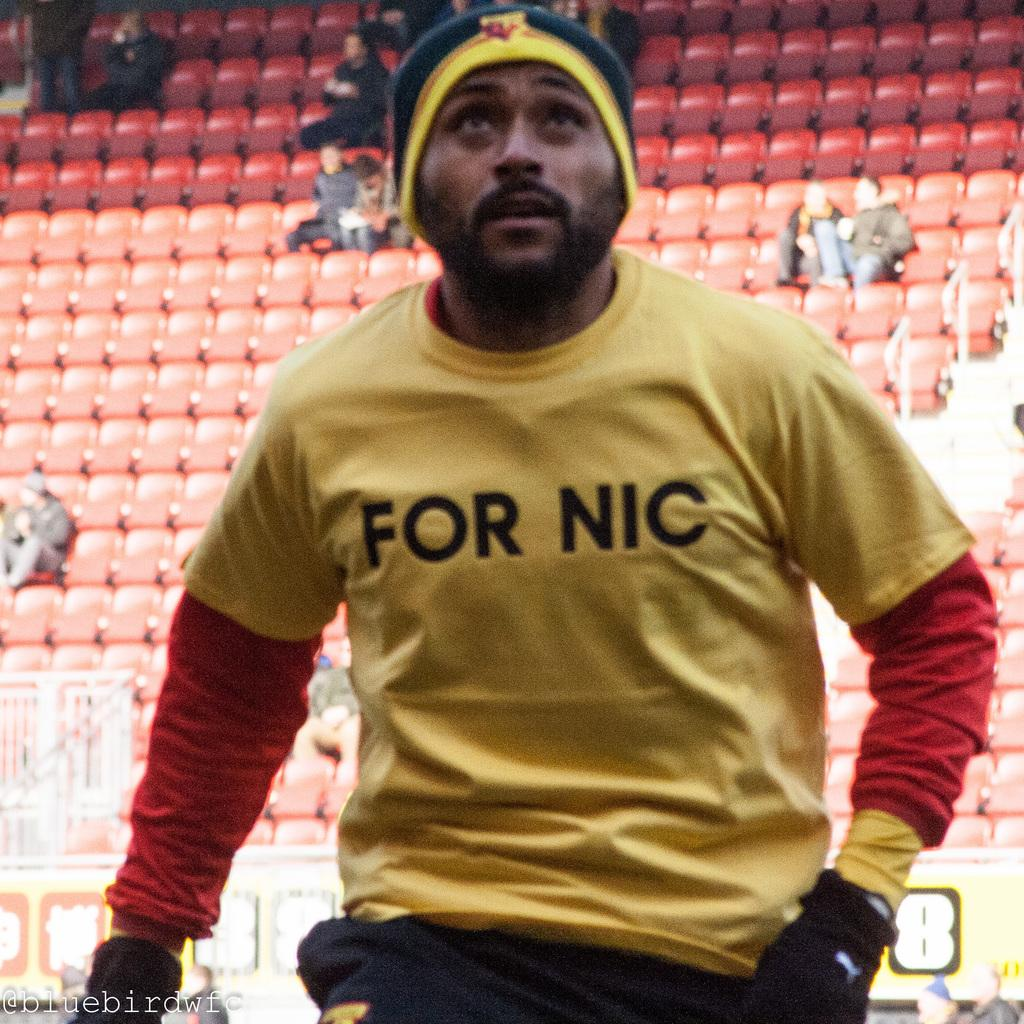Who or what is the main subject in the image? There is a person in the image. What can be observed about the background of the image? The background of the image is blurred. What type of furniture is present in the image? There are chairs in the image. How many people are visible in the image? There are people in the image, and some of them are sitting on the chairs. What is the purpose of the watermark at the bottom of the image? The watermark at the bottom of the image is likely for copyright or identification purposes. How many geese are visible in the image? There are no geese present in the image. What type of knife is being used by the person in the image? There is no knife visible in the image. 